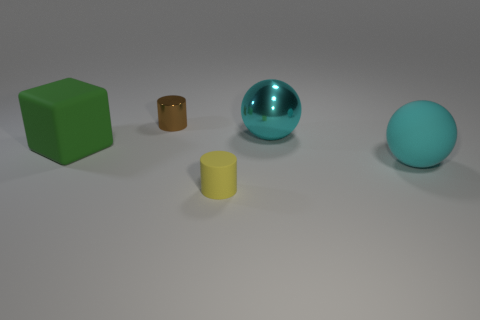Is the material of the large cyan thing in front of the green rubber block the same as the brown object?
Make the answer very short. No. Is the number of matte things less than the number of tiny rubber objects?
Provide a short and direct response. No. Is there a matte thing left of the cyan object behind the big ball in front of the cyan shiny object?
Provide a short and direct response. Yes. Does the cyan thing that is behind the big cyan rubber sphere have the same shape as the small yellow thing?
Keep it short and to the point. No. Are there more small brown objects to the left of the tiny yellow rubber thing than blue rubber cubes?
Make the answer very short. Yes. Do the ball behind the big cube and the rubber sphere have the same color?
Your response must be concise. Yes. Are there any other things that are the same color as the metal sphere?
Ensure brevity in your answer.  Yes. There is a block that is in front of the cyan metal sphere right of the large green thing that is on the left side of the shiny sphere; what is its color?
Give a very brief answer. Green. Is the cyan rubber thing the same size as the yellow object?
Provide a short and direct response. No. How many matte things have the same size as the green block?
Make the answer very short. 1. 